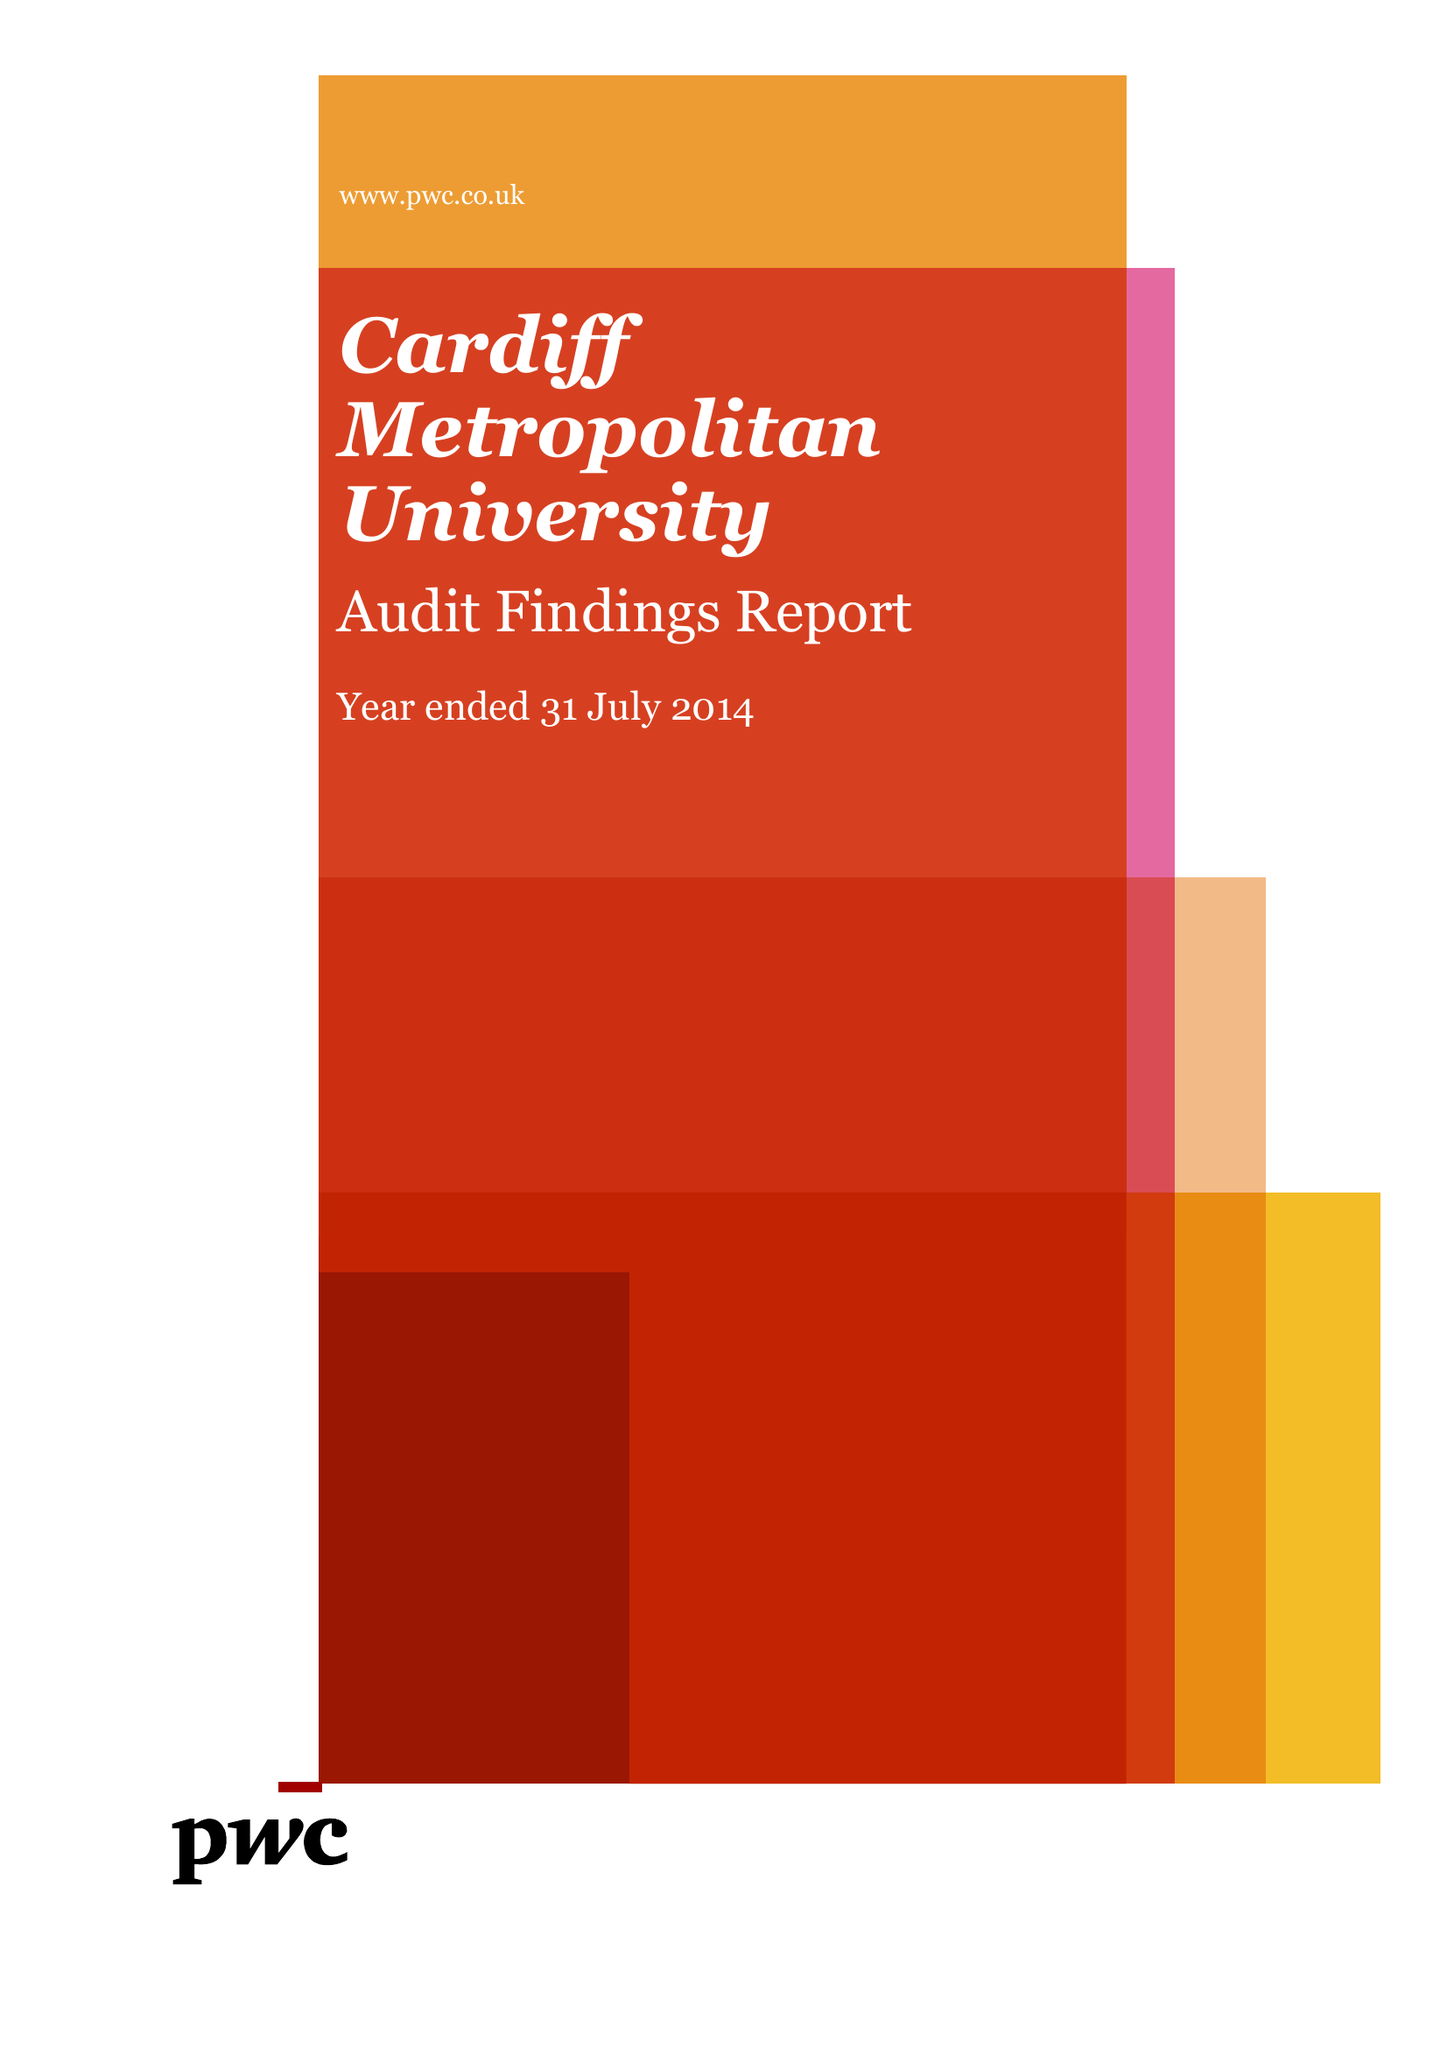What is the value for the charity_number?
Answer the question using a single word or phrase. 1140762 